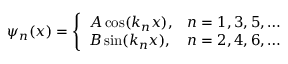<formula> <loc_0><loc_0><loc_500><loc_500>\psi _ { n } ( x ) = { \left \{ \begin{array} { l l } { A \cos ( k _ { n } x ) , } & { n = 1 , 3 , 5 , \dots } \\ { B \sin ( k _ { n } x ) , } & { n = 2 , 4 , 6 , \dots } \end{array} }</formula> 